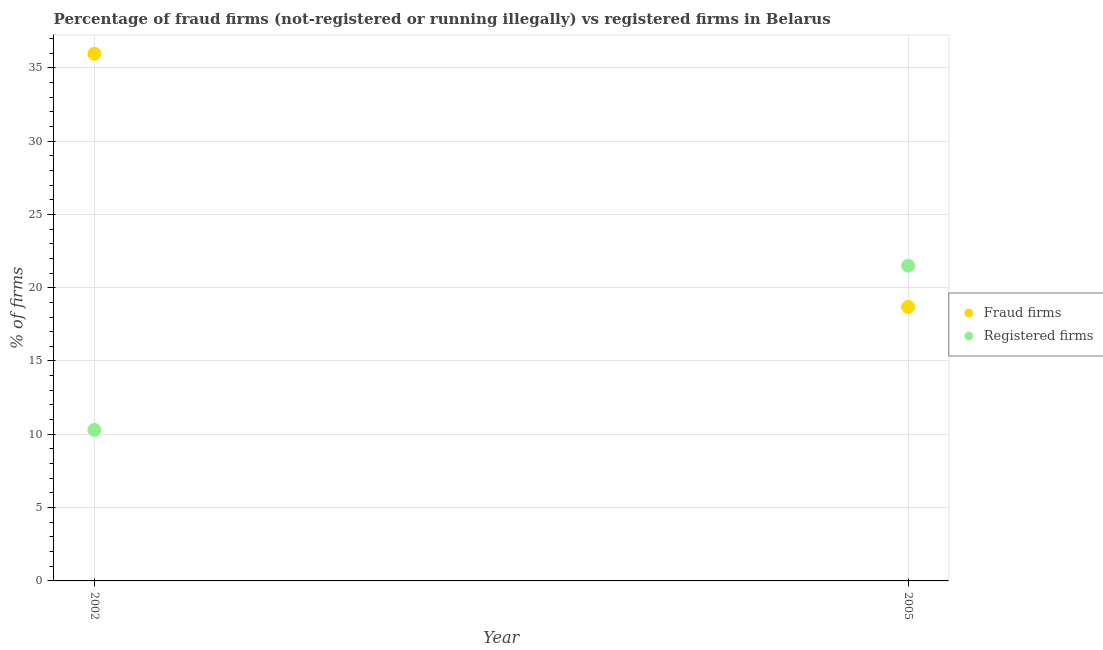How many different coloured dotlines are there?
Keep it short and to the point. 2. What is the percentage of registered firms in 2002?
Keep it short and to the point. 10.3. Across all years, what is the minimum percentage of registered firms?
Offer a terse response. 10.3. In which year was the percentage of registered firms minimum?
Your response must be concise. 2002. What is the total percentage of registered firms in the graph?
Your answer should be very brief. 31.8. What is the difference between the percentage of fraud firms in 2002 and that in 2005?
Your answer should be very brief. 17.27. What is the difference between the percentage of registered firms in 2002 and the percentage of fraud firms in 2005?
Ensure brevity in your answer.  -8.39. What is the average percentage of registered firms per year?
Your answer should be compact. 15.9. In the year 2002, what is the difference between the percentage of fraud firms and percentage of registered firms?
Your answer should be very brief. 25.66. What is the ratio of the percentage of fraud firms in 2002 to that in 2005?
Your response must be concise. 1.92. Is the percentage of registered firms strictly greater than the percentage of fraud firms over the years?
Provide a succinct answer. No. How many years are there in the graph?
Ensure brevity in your answer.  2. Are the values on the major ticks of Y-axis written in scientific E-notation?
Your answer should be compact. No. Does the graph contain grids?
Your response must be concise. Yes. Where does the legend appear in the graph?
Your answer should be compact. Center right. How are the legend labels stacked?
Give a very brief answer. Vertical. What is the title of the graph?
Your answer should be compact. Percentage of fraud firms (not-registered or running illegally) vs registered firms in Belarus. Does "Excluding technical cooperation" appear as one of the legend labels in the graph?
Ensure brevity in your answer.  No. What is the label or title of the X-axis?
Offer a very short reply. Year. What is the label or title of the Y-axis?
Your answer should be very brief. % of firms. What is the % of firms in Fraud firms in 2002?
Your answer should be very brief. 35.96. What is the % of firms in Registered firms in 2002?
Your response must be concise. 10.3. What is the % of firms in Fraud firms in 2005?
Your answer should be compact. 18.69. What is the % of firms of Registered firms in 2005?
Provide a short and direct response. 21.5. Across all years, what is the maximum % of firms of Fraud firms?
Your response must be concise. 35.96. Across all years, what is the minimum % of firms of Fraud firms?
Provide a succinct answer. 18.69. What is the total % of firms in Fraud firms in the graph?
Provide a short and direct response. 54.65. What is the total % of firms in Registered firms in the graph?
Make the answer very short. 31.8. What is the difference between the % of firms of Fraud firms in 2002 and that in 2005?
Your response must be concise. 17.27. What is the difference between the % of firms in Registered firms in 2002 and that in 2005?
Your response must be concise. -11.2. What is the difference between the % of firms in Fraud firms in 2002 and the % of firms in Registered firms in 2005?
Ensure brevity in your answer.  14.46. What is the average % of firms of Fraud firms per year?
Offer a terse response. 27.32. What is the average % of firms in Registered firms per year?
Make the answer very short. 15.9. In the year 2002, what is the difference between the % of firms in Fraud firms and % of firms in Registered firms?
Give a very brief answer. 25.66. In the year 2005, what is the difference between the % of firms in Fraud firms and % of firms in Registered firms?
Provide a succinct answer. -2.81. What is the ratio of the % of firms in Fraud firms in 2002 to that in 2005?
Your answer should be very brief. 1.92. What is the ratio of the % of firms of Registered firms in 2002 to that in 2005?
Give a very brief answer. 0.48. What is the difference between the highest and the second highest % of firms in Fraud firms?
Keep it short and to the point. 17.27. What is the difference between the highest and the second highest % of firms in Registered firms?
Make the answer very short. 11.2. What is the difference between the highest and the lowest % of firms of Fraud firms?
Your response must be concise. 17.27. What is the difference between the highest and the lowest % of firms of Registered firms?
Provide a succinct answer. 11.2. 